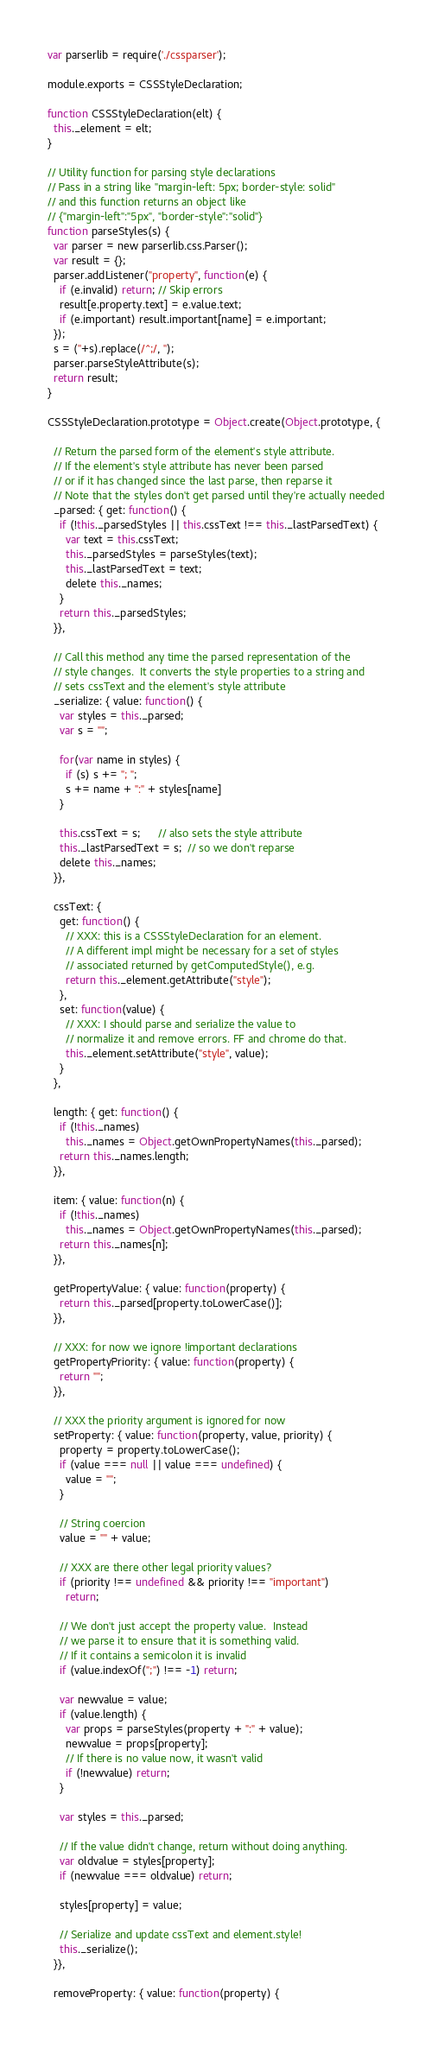<code> <loc_0><loc_0><loc_500><loc_500><_JavaScript_>var parserlib = require('./cssparser');

module.exports = CSSStyleDeclaration;

function CSSStyleDeclaration(elt) {
  this._element = elt;
}

// Utility function for parsing style declarations
// Pass in a string like "margin-left: 5px; border-style: solid"
// and this function returns an object like
// {"margin-left":"5px", "border-style":"solid"}
function parseStyles(s) {
  var parser = new parserlib.css.Parser();
  var result = {};
  parser.addListener("property", function(e) {
    if (e.invalid) return; // Skip errors
    result[e.property.text] = e.value.text;
    if (e.important) result.important[name] = e.important;
  });
  s = (''+s).replace(/^;/, '');
  parser.parseStyleAttribute(s);
  return result;
}

CSSStyleDeclaration.prototype = Object.create(Object.prototype, {

  // Return the parsed form of the element's style attribute.
  // If the element's style attribute has never been parsed
  // or if it has changed since the last parse, then reparse it
  // Note that the styles don't get parsed until they're actually needed
  _parsed: { get: function() {
    if (!this._parsedStyles || this.cssText !== this._lastParsedText) {
      var text = this.cssText;
      this._parsedStyles = parseStyles(text);
      this._lastParsedText = text;
      delete this._names;
    }
    return this._parsedStyles;
  }},

  // Call this method any time the parsed representation of the
  // style changes.  It converts the style properties to a string and
  // sets cssText and the element's style attribute
  _serialize: { value: function() {
    var styles = this._parsed;
    var s = "";

    for(var name in styles) {
      if (s) s += "; ";
      s += name + ":" + styles[name]
    }

    this.cssText = s;      // also sets the style attribute
    this._lastParsedText = s;  // so we don't reparse
    delete this._names;
  }},

  cssText: {
    get: function() {
      // XXX: this is a CSSStyleDeclaration for an element.
      // A different impl might be necessary for a set of styles
      // associated returned by getComputedStyle(), e.g.
      return this._element.getAttribute("style");
    },
    set: function(value) {
      // XXX: I should parse and serialize the value to
      // normalize it and remove errors. FF and chrome do that.
      this._element.setAttribute("style", value);
    }
  },

  length: { get: function() {
    if (!this._names)
      this._names = Object.getOwnPropertyNames(this._parsed);
    return this._names.length;
  }},

  item: { value: function(n) {
    if (!this._names)
      this._names = Object.getOwnPropertyNames(this._parsed);
    return this._names[n];
  }},

  getPropertyValue: { value: function(property) {
    return this._parsed[property.toLowerCase()];
  }},

  // XXX: for now we ignore !important declarations
  getPropertyPriority: { value: function(property) {
    return "";
  }},

  // XXX the priority argument is ignored for now
  setProperty: { value: function(property, value, priority) {
    property = property.toLowerCase();
    if (value === null || value === undefined) {
      value = "";
    }

    // String coercion
    value = "" + value;

    // XXX are there other legal priority values?
    if (priority !== undefined && priority !== "important")
      return;

    // We don't just accept the property value.  Instead
    // we parse it to ensure that it is something valid.
    // If it contains a semicolon it is invalid
    if (value.indexOf(";") !== -1) return;

    var newvalue = value;
    if (value.length) {
      var props = parseStyles(property + ":" + value);
      newvalue = props[property];
      // If there is no value now, it wasn't valid
      if (!newvalue) return;
    }

    var styles = this._parsed;

    // If the value didn't change, return without doing anything.
    var oldvalue = styles[property];
    if (newvalue === oldvalue) return;

    styles[property] = value;

    // Serialize and update cssText and element.style!
    this._serialize();
  }},

  removeProperty: { value: function(property) {</code> 